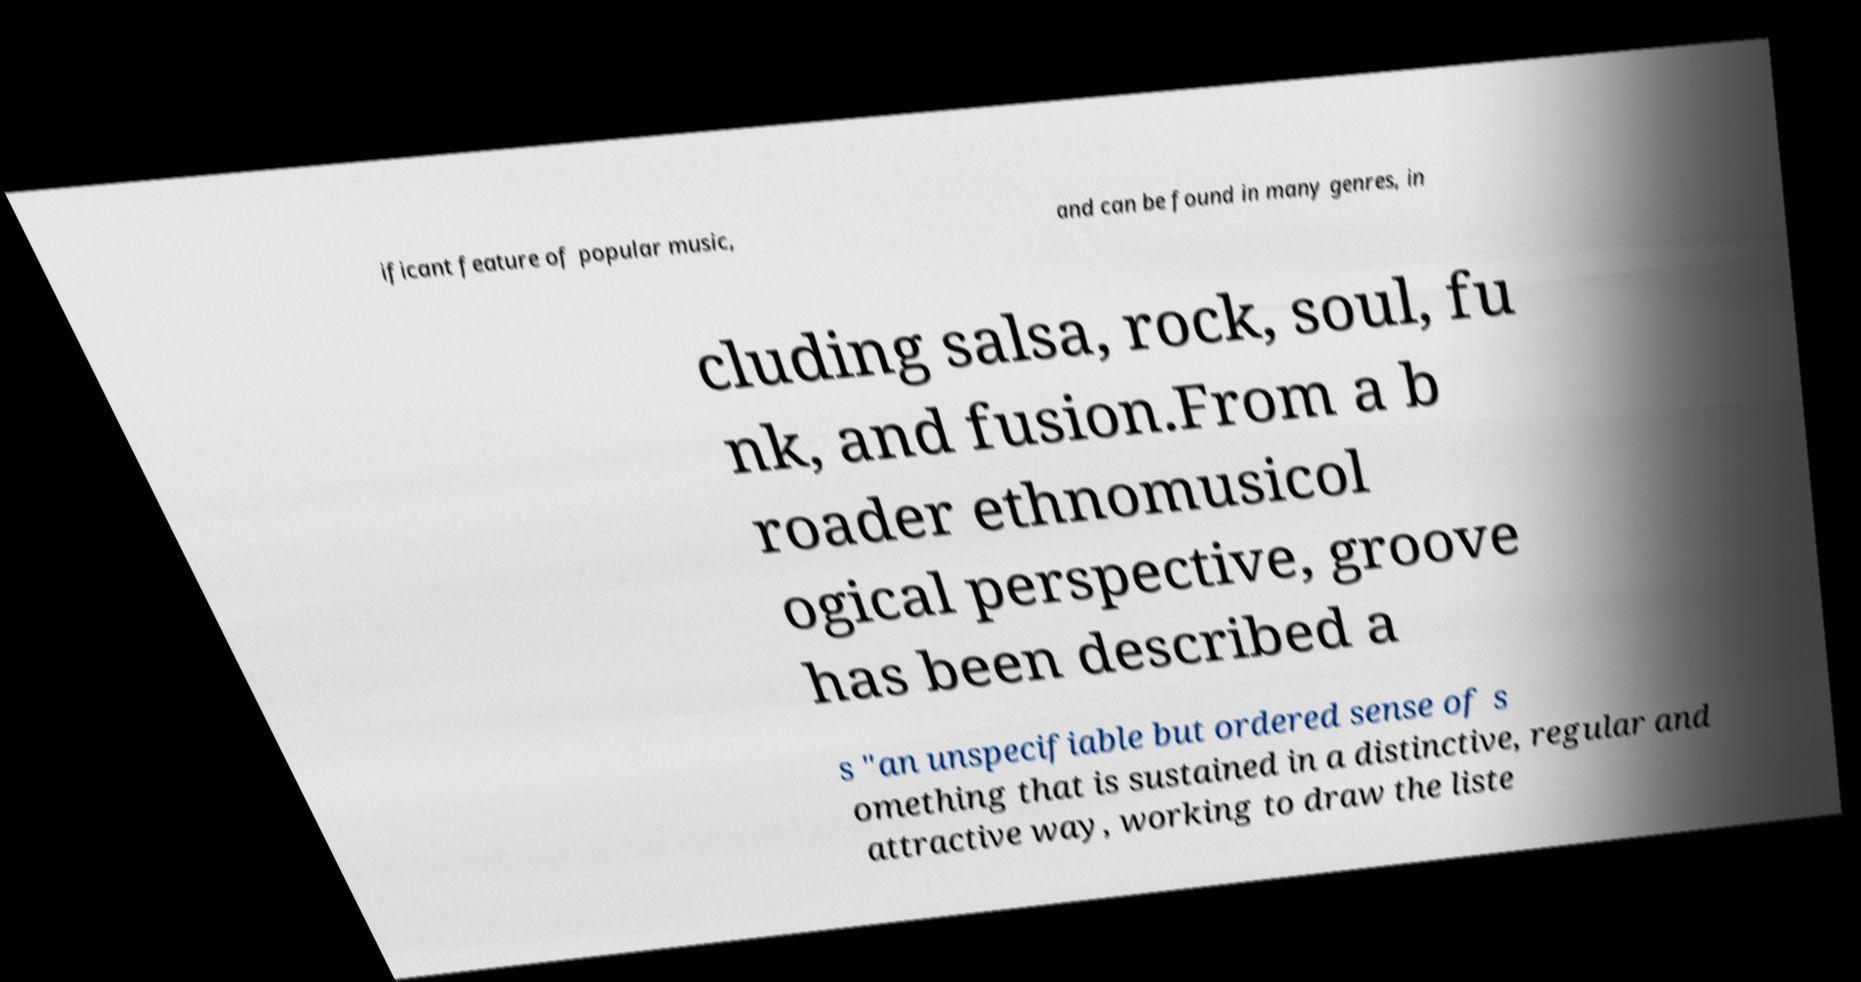For documentation purposes, I need the text within this image transcribed. Could you provide that? ificant feature of popular music, and can be found in many genres, in cluding salsa, rock, soul, fu nk, and fusion.From a b roader ethnomusicol ogical perspective, groove has been described a s "an unspecifiable but ordered sense of s omething that is sustained in a distinctive, regular and attractive way, working to draw the liste 